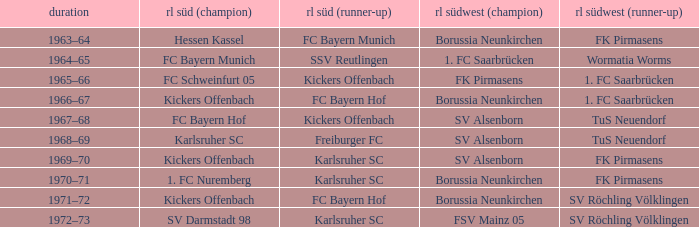In which season was freiburger fc the runner-up in rl süd? 1968–69. 